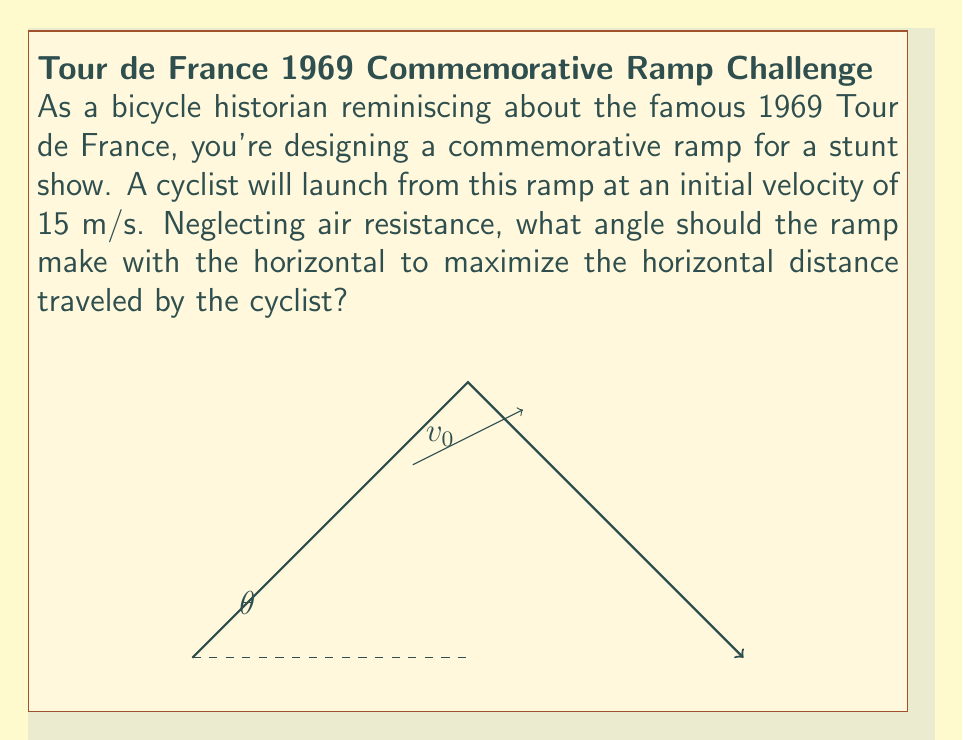What is the answer to this math problem? Let's approach this step-by-step:

1) The trajectory of the cyclist after leaving the ramp follows a parabolic path described by projectile motion equations.

2) The horizontal distance (R) traveled is given by:

   $$R = \frac{v_0^2 \sin(2\theta)}{g}$$

   where $v_0$ is the initial velocity, $\theta$ is the angle of the ramp, and $g$ is the acceleration due to gravity (9.8 m/s²).

3) To find the maximum distance, we need to find the angle $\theta$ that maximizes this function. We can do this by differentiating R with respect to $\theta$ and setting it to zero:

   $$\frac{dR}{d\theta} = \frac{v_0^2 \cdot 2\cos(2\theta)}{g} = 0$$

4) This equation is satisfied when $\cos(2\theta) = 0$, which occurs when $2\theta = 90°$ or $\theta = 45°$.

5) To confirm this is a maximum (not a minimum), we can check the second derivative:

   $$\frac{d^2R}{d\theta^2} = -\frac{4v_0^2 \sin(2\theta)}{g}$$

   At $\theta = 45°$, this is negative, confirming a maximum.

6) Therefore, the optimal angle to maximize the horizontal distance is 45°.

This result is independent of the initial velocity, so it applies for any speed the cyclist might achieve.
Answer: 45° 